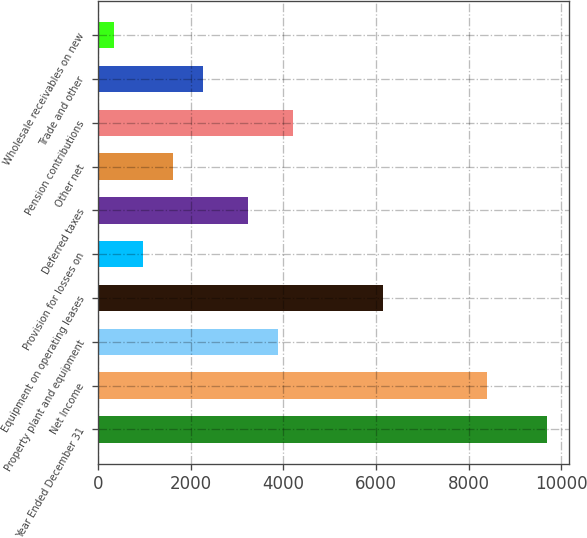Convert chart to OTSL. <chart><loc_0><loc_0><loc_500><loc_500><bar_chart><fcel>Year Ended December 31<fcel>Net Income<fcel>Property plant and equipment<fcel>Equipment on operating leases<fcel>Provision for losses on<fcel>Deferred taxes<fcel>Other net<fcel>Pension contributions<fcel>Trade and other<fcel>Wholesale receivables on new<nl><fcel>9695.1<fcel>8403.18<fcel>3881.46<fcel>6142.32<fcel>974.64<fcel>3235.5<fcel>1620.6<fcel>4204.44<fcel>2266.56<fcel>328.68<nl></chart> 